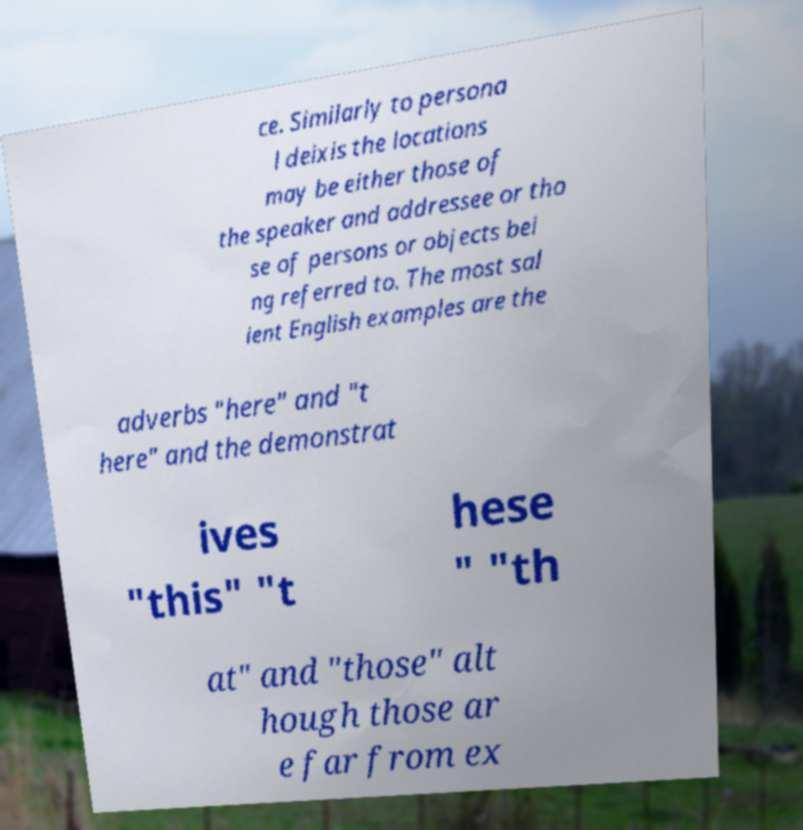Could you assist in decoding the text presented in this image and type it out clearly? ce. Similarly to persona l deixis the locations may be either those of the speaker and addressee or tho se of persons or objects bei ng referred to. The most sal ient English examples are the adverbs "here" and "t here" and the demonstrat ives "this" "t hese " "th at" and "those" alt hough those ar e far from ex 